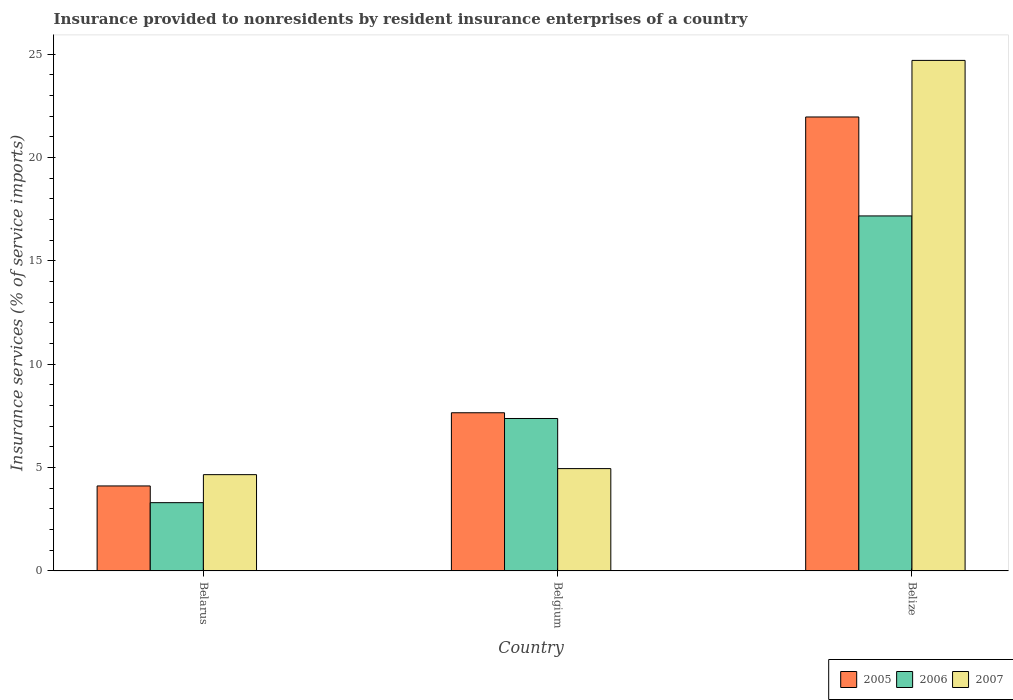How many groups of bars are there?
Ensure brevity in your answer.  3. Are the number of bars on each tick of the X-axis equal?
Offer a very short reply. Yes. How many bars are there on the 2nd tick from the left?
Make the answer very short. 3. In how many cases, is the number of bars for a given country not equal to the number of legend labels?
Your answer should be very brief. 0. What is the insurance provided to nonresidents in 2006 in Belgium?
Your answer should be very brief. 7.37. Across all countries, what is the maximum insurance provided to nonresidents in 2007?
Ensure brevity in your answer.  24.7. Across all countries, what is the minimum insurance provided to nonresidents in 2007?
Your response must be concise. 4.66. In which country was the insurance provided to nonresidents in 2005 maximum?
Give a very brief answer. Belize. In which country was the insurance provided to nonresidents in 2006 minimum?
Keep it short and to the point. Belarus. What is the total insurance provided to nonresidents in 2005 in the graph?
Offer a terse response. 33.73. What is the difference between the insurance provided to nonresidents in 2006 in Belarus and that in Belgium?
Your answer should be very brief. -4.07. What is the difference between the insurance provided to nonresidents in 2006 in Belize and the insurance provided to nonresidents in 2007 in Belarus?
Provide a short and direct response. 12.52. What is the average insurance provided to nonresidents in 2005 per country?
Your answer should be compact. 11.24. What is the difference between the insurance provided to nonresidents of/in 2007 and insurance provided to nonresidents of/in 2006 in Belize?
Give a very brief answer. 7.53. What is the ratio of the insurance provided to nonresidents in 2006 in Belgium to that in Belize?
Provide a short and direct response. 0.43. Is the difference between the insurance provided to nonresidents in 2007 in Belarus and Belize greater than the difference between the insurance provided to nonresidents in 2006 in Belarus and Belize?
Keep it short and to the point. No. What is the difference between the highest and the second highest insurance provided to nonresidents in 2005?
Ensure brevity in your answer.  -17.85. What is the difference between the highest and the lowest insurance provided to nonresidents in 2007?
Provide a succinct answer. 20.04. Is the sum of the insurance provided to nonresidents in 2006 in Belarus and Belgium greater than the maximum insurance provided to nonresidents in 2007 across all countries?
Provide a short and direct response. No. What does the 3rd bar from the left in Belarus represents?
Provide a short and direct response. 2007. What does the 2nd bar from the right in Belize represents?
Offer a very short reply. 2006. How many bars are there?
Your answer should be very brief. 9. Are the values on the major ticks of Y-axis written in scientific E-notation?
Offer a terse response. No. Does the graph contain any zero values?
Provide a succinct answer. No. Does the graph contain grids?
Give a very brief answer. No. What is the title of the graph?
Your answer should be very brief. Insurance provided to nonresidents by resident insurance enterprises of a country. Does "1984" appear as one of the legend labels in the graph?
Offer a very short reply. No. What is the label or title of the Y-axis?
Offer a terse response. Insurance services (% of service imports). What is the Insurance services (% of service imports) of 2005 in Belarus?
Offer a terse response. 4.11. What is the Insurance services (% of service imports) of 2006 in Belarus?
Your response must be concise. 3.3. What is the Insurance services (% of service imports) of 2007 in Belarus?
Your response must be concise. 4.66. What is the Insurance services (% of service imports) of 2005 in Belgium?
Provide a succinct answer. 7.65. What is the Insurance services (% of service imports) in 2006 in Belgium?
Offer a terse response. 7.37. What is the Insurance services (% of service imports) of 2007 in Belgium?
Your response must be concise. 4.95. What is the Insurance services (% of service imports) in 2005 in Belize?
Your answer should be compact. 21.96. What is the Insurance services (% of service imports) in 2006 in Belize?
Provide a short and direct response. 17.18. What is the Insurance services (% of service imports) of 2007 in Belize?
Make the answer very short. 24.7. Across all countries, what is the maximum Insurance services (% of service imports) of 2005?
Ensure brevity in your answer.  21.96. Across all countries, what is the maximum Insurance services (% of service imports) of 2006?
Make the answer very short. 17.18. Across all countries, what is the maximum Insurance services (% of service imports) in 2007?
Provide a short and direct response. 24.7. Across all countries, what is the minimum Insurance services (% of service imports) in 2005?
Make the answer very short. 4.11. Across all countries, what is the minimum Insurance services (% of service imports) of 2006?
Give a very brief answer. 3.3. Across all countries, what is the minimum Insurance services (% of service imports) of 2007?
Provide a short and direct response. 4.66. What is the total Insurance services (% of service imports) in 2005 in the graph?
Offer a very short reply. 33.73. What is the total Insurance services (% of service imports) of 2006 in the graph?
Keep it short and to the point. 27.85. What is the total Insurance services (% of service imports) of 2007 in the graph?
Provide a short and direct response. 34.31. What is the difference between the Insurance services (% of service imports) in 2005 in Belarus and that in Belgium?
Offer a very short reply. -3.54. What is the difference between the Insurance services (% of service imports) in 2006 in Belarus and that in Belgium?
Offer a very short reply. -4.07. What is the difference between the Insurance services (% of service imports) in 2007 in Belarus and that in Belgium?
Keep it short and to the point. -0.29. What is the difference between the Insurance services (% of service imports) of 2005 in Belarus and that in Belize?
Offer a very short reply. -17.85. What is the difference between the Insurance services (% of service imports) in 2006 in Belarus and that in Belize?
Your answer should be very brief. -13.87. What is the difference between the Insurance services (% of service imports) of 2007 in Belarus and that in Belize?
Ensure brevity in your answer.  -20.05. What is the difference between the Insurance services (% of service imports) of 2005 in Belgium and that in Belize?
Your response must be concise. -14.31. What is the difference between the Insurance services (% of service imports) in 2006 in Belgium and that in Belize?
Your response must be concise. -9.8. What is the difference between the Insurance services (% of service imports) of 2007 in Belgium and that in Belize?
Provide a short and direct response. -19.75. What is the difference between the Insurance services (% of service imports) of 2005 in Belarus and the Insurance services (% of service imports) of 2006 in Belgium?
Your answer should be very brief. -3.26. What is the difference between the Insurance services (% of service imports) of 2005 in Belarus and the Insurance services (% of service imports) of 2007 in Belgium?
Make the answer very short. -0.84. What is the difference between the Insurance services (% of service imports) in 2006 in Belarus and the Insurance services (% of service imports) in 2007 in Belgium?
Keep it short and to the point. -1.65. What is the difference between the Insurance services (% of service imports) in 2005 in Belarus and the Insurance services (% of service imports) in 2006 in Belize?
Offer a very short reply. -13.07. What is the difference between the Insurance services (% of service imports) of 2005 in Belarus and the Insurance services (% of service imports) of 2007 in Belize?
Give a very brief answer. -20.59. What is the difference between the Insurance services (% of service imports) of 2006 in Belarus and the Insurance services (% of service imports) of 2007 in Belize?
Offer a very short reply. -21.4. What is the difference between the Insurance services (% of service imports) of 2005 in Belgium and the Insurance services (% of service imports) of 2006 in Belize?
Give a very brief answer. -9.52. What is the difference between the Insurance services (% of service imports) of 2005 in Belgium and the Insurance services (% of service imports) of 2007 in Belize?
Your response must be concise. -17.05. What is the difference between the Insurance services (% of service imports) in 2006 in Belgium and the Insurance services (% of service imports) in 2007 in Belize?
Provide a short and direct response. -17.33. What is the average Insurance services (% of service imports) in 2005 per country?
Keep it short and to the point. 11.24. What is the average Insurance services (% of service imports) in 2006 per country?
Give a very brief answer. 9.28. What is the average Insurance services (% of service imports) of 2007 per country?
Keep it short and to the point. 11.44. What is the difference between the Insurance services (% of service imports) in 2005 and Insurance services (% of service imports) in 2006 in Belarus?
Give a very brief answer. 0.81. What is the difference between the Insurance services (% of service imports) of 2005 and Insurance services (% of service imports) of 2007 in Belarus?
Your answer should be very brief. -0.55. What is the difference between the Insurance services (% of service imports) in 2006 and Insurance services (% of service imports) in 2007 in Belarus?
Offer a terse response. -1.36. What is the difference between the Insurance services (% of service imports) in 2005 and Insurance services (% of service imports) in 2006 in Belgium?
Provide a succinct answer. 0.28. What is the difference between the Insurance services (% of service imports) in 2005 and Insurance services (% of service imports) in 2007 in Belgium?
Offer a very short reply. 2.7. What is the difference between the Insurance services (% of service imports) in 2006 and Insurance services (% of service imports) in 2007 in Belgium?
Your response must be concise. 2.42. What is the difference between the Insurance services (% of service imports) of 2005 and Insurance services (% of service imports) of 2006 in Belize?
Give a very brief answer. 4.79. What is the difference between the Insurance services (% of service imports) in 2005 and Insurance services (% of service imports) in 2007 in Belize?
Keep it short and to the point. -2.74. What is the difference between the Insurance services (% of service imports) of 2006 and Insurance services (% of service imports) of 2007 in Belize?
Provide a succinct answer. -7.53. What is the ratio of the Insurance services (% of service imports) in 2005 in Belarus to that in Belgium?
Provide a succinct answer. 0.54. What is the ratio of the Insurance services (% of service imports) of 2006 in Belarus to that in Belgium?
Offer a very short reply. 0.45. What is the ratio of the Insurance services (% of service imports) of 2007 in Belarus to that in Belgium?
Give a very brief answer. 0.94. What is the ratio of the Insurance services (% of service imports) in 2005 in Belarus to that in Belize?
Your answer should be very brief. 0.19. What is the ratio of the Insurance services (% of service imports) of 2006 in Belarus to that in Belize?
Offer a very short reply. 0.19. What is the ratio of the Insurance services (% of service imports) of 2007 in Belarus to that in Belize?
Offer a very short reply. 0.19. What is the ratio of the Insurance services (% of service imports) of 2005 in Belgium to that in Belize?
Give a very brief answer. 0.35. What is the ratio of the Insurance services (% of service imports) in 2006 in Belgium to that in Belize?
Your response must be concise. 0.43. What is the ratio of the Insurance services (% of service imports) of 2007 in Belgium to that in Belize?
Keep it short and to the point. 0.2. What is the difference between the highest and the second highest Insurance services (% of service imports) in 2005?
Ensure brevity in your answer.  14.31. What is the difference between the highest and the second highest Insurance services (% of service imports) of 2006?
Ensure brevity in your answer.  9.8. What is the difference between the highest and the second highest Insurance services (% of service imports) of 2007?
Provide a short and direct response. 19.75. What is the difference between the highest and the lowest Insurance services (% of service imports) in 2005?
Your response must be concise. 17.85. What is the difference between the highest and the lowest Insurance services (% of service imports) in 2006?
Your answer should be very brief. 13.87. What is the difference between the highest and the lowest Insurance services (% of service imports) in 2007?
Ensure brevity in your answer.  20.05. 